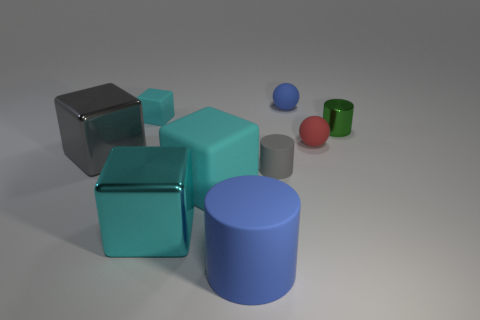Do the rubber thing in front of the large cyan matte object and the object that is on the left side of the tiny cyan block have the same shape?
Give a very brief answer. No. The thing that is both on the right side of the small matte cylinder and on the left side of the red matte ball is what color?
Offer a very short reply. Blue. Is the color of the big rubber cylinder the same as the ball that is behind the red object?
Ensure brevity in your answer.  Yes. How big is the object that is both on the left side of the blue ball and behind the small green metallic thing?
Make the answer very short. Small. What number of other things are there of the same color as the shiny cylinder?
Offer a very short reply. 0. There is a cyan matte cube that is behind the rubber cube that is in front of the ball that is in front of the green metallic cylinder; what size is it?
Provide a short and direct response. Small. There is a red matte thing; are there any tiny red matte objects behind it?
Your answer should be compact. No. Is the size of the red matte ball the same as the cube behind the metallic cylinder?
Offer a terse response. Yes. What number of other objects are there of the same material as the gray cylinder?
Offer a very short reply. 5. What shape is the matte thing that is both in front of the tiny rubber block and behind the large gray thing?
Offer a terse response. Sphere. 